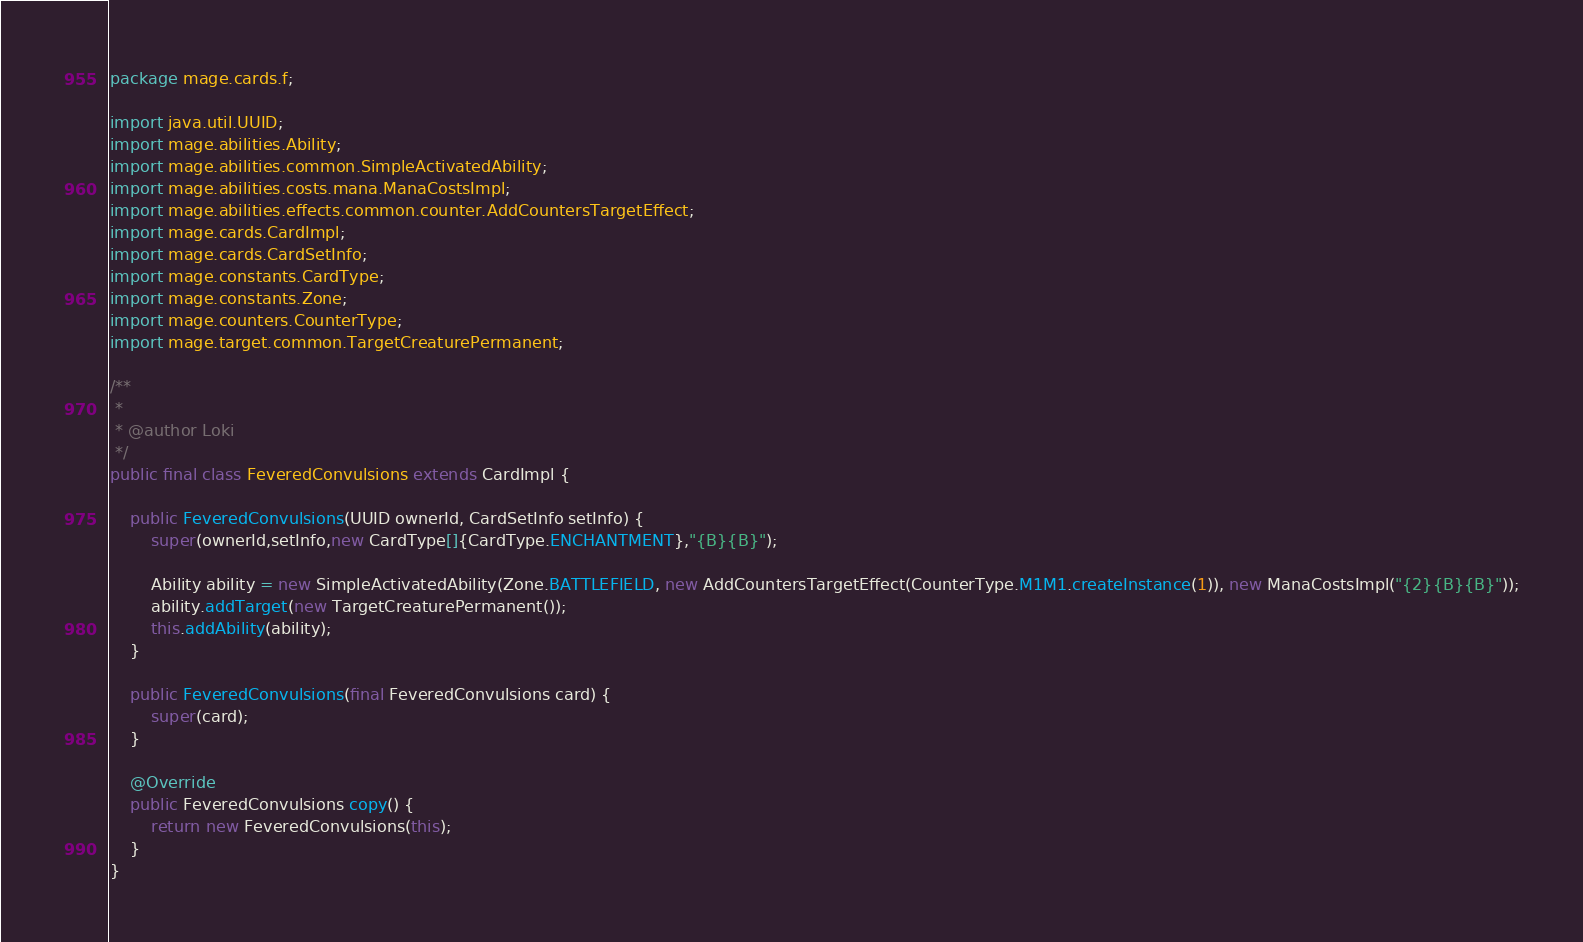<code> <loc_0><loc_0><loc_500><loc_500><_Java_>
package mage.cards.f;

import java.util.UUID;
import mage.abilities.Ability;
import mage.abilities.common.SimpleActivatedAbility;
import mage.abilities.costs.mana.ManaCostsImpl;
import mage.abilities.effects.common.counter.AddCountersTargetEffect;
import mage.cards.CardImpl;
import mage.cards.CardSetInfo;
import mage.constants.CardType;
import mage.constants.Zone;
import mage.counters.CounterType;
import mage.target.common.TargetCreaturePermanent;

/**
 *
 * @author Loki
 */
public final class FeveredConvulsions extends CardImpl {

    public FeveredConvulsions(UUID ownerId, CardSetInfo setInfo) {
        super(ownerId,setInfo,new CardType[]{CardType.ENCHANTMENT},"{B}{B}");

        Ability ability = new SimpleActivatedAbility(Zone.BATTLEFIELD, new AddCountersTargetEffect(CounterType.M1M1.createInstance(1)), new ManaCostsImpl("{2}{B}{B}"));
        ability.addTarget(new TargetCreaturePermanent());
        this.addAbility(ability);
    }

    public FeveredConvulsions(final FeveredConvulsions card) {
        super(card);
    }

    @Override
    public FeveredConvulsions copy() {
        return new FeveredConvulsions(this);
    }
}
</code> 